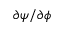Convert formula to latex. <formula><loc_0><loc_0><loc_500><loc_500>\partial \psi / \partial \phi</formula> 